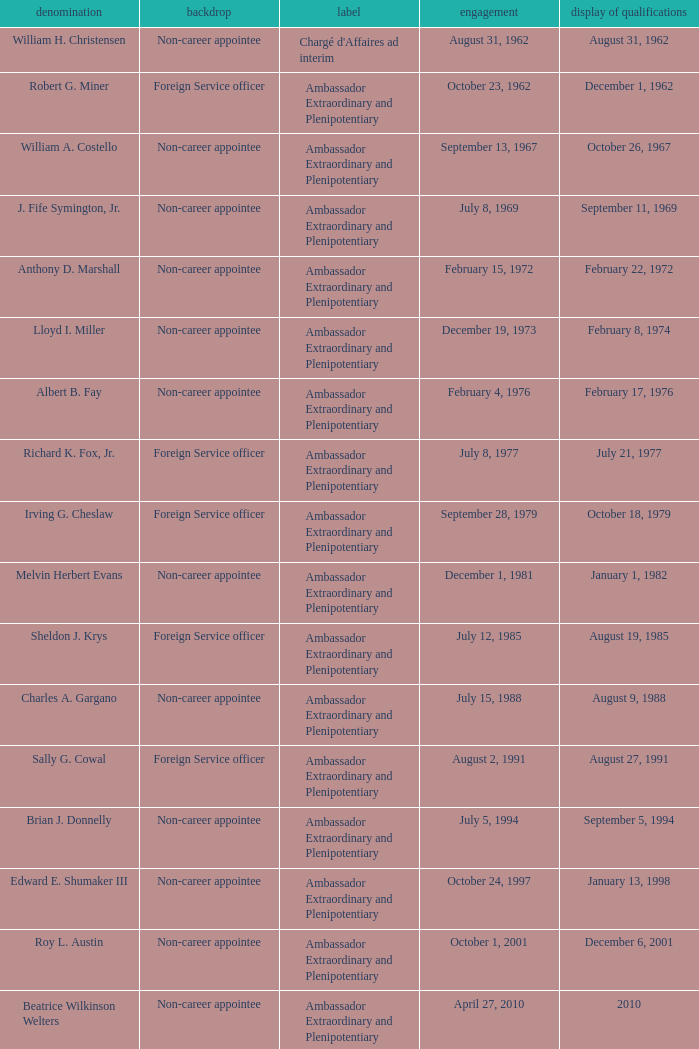What was Anthony D. Marshall's title? Ambassador Extraordinary and Plenipotentiary. 